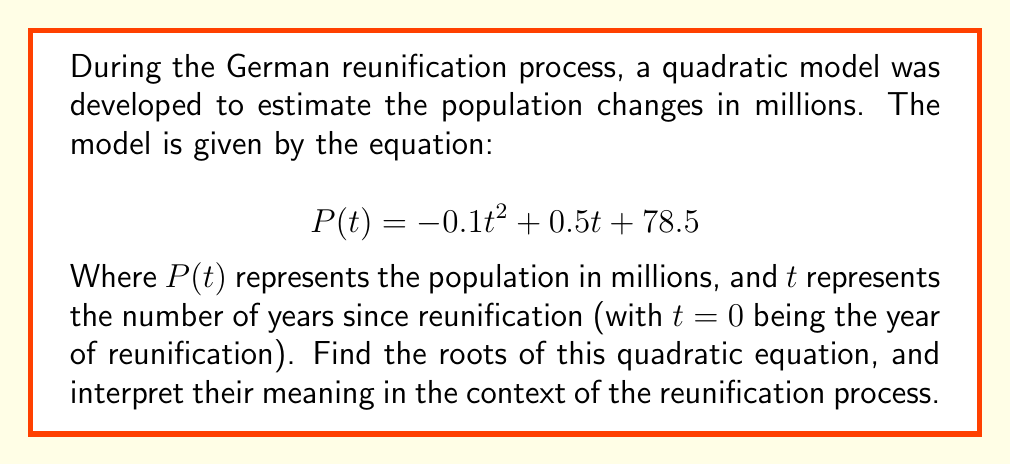What is the answer to this math problem? To find the roots of the quadratic equation, we need to solve $P(t) = 0$:

1) Set the equation equal to zero:
   $$-0.1t^2 + 0.5t + 78.5 = 0$$

2) This is in the standard form $at^2 + bt + c = 0$, where:
   $a = -0.1$, $b = 0.5$, and $c = 78.5$

3) We can use the quadratic formula: $t = \frac{-b \pm \sqrt{b^2 - 4ac}}{2a}$

4) Substituting our values:
   $$t = \frac{-0.5 \pm \sqrt{0.5^2 - 4(-0.1)(78.5)}}{2(-0.1)}$$

5) Simplify under the square root:
   $$t = \frac{-0.5 \pm \sqrt{0.25 + 31.4}}{-0.2} = \frac{-0.5 \pm \sqrt{31.65}}{-0.2}$$

6) Simplify further:
   $$t = \frac{-0.5 \pm 5.626}{-0.2}$$

7) This gives us two solutions:
   $$t_1 = \frac{-0.5 + 5.626}{-0.2} = -25.63$$
   $$t_2 = \frac{-0.5 - 5.626}{-0.2} = 30.63$$

Interpretation: The negative root (-25.63) occurs before the reunification and doesn't have a practical meaning in this context. The positive root (30.63) suggests that, according to this model, the population would return to its initial level about 30.63 years after reunification if the trend continued.
Answer: $t_1 = -25.63$, $t_2 = 30.63$ 